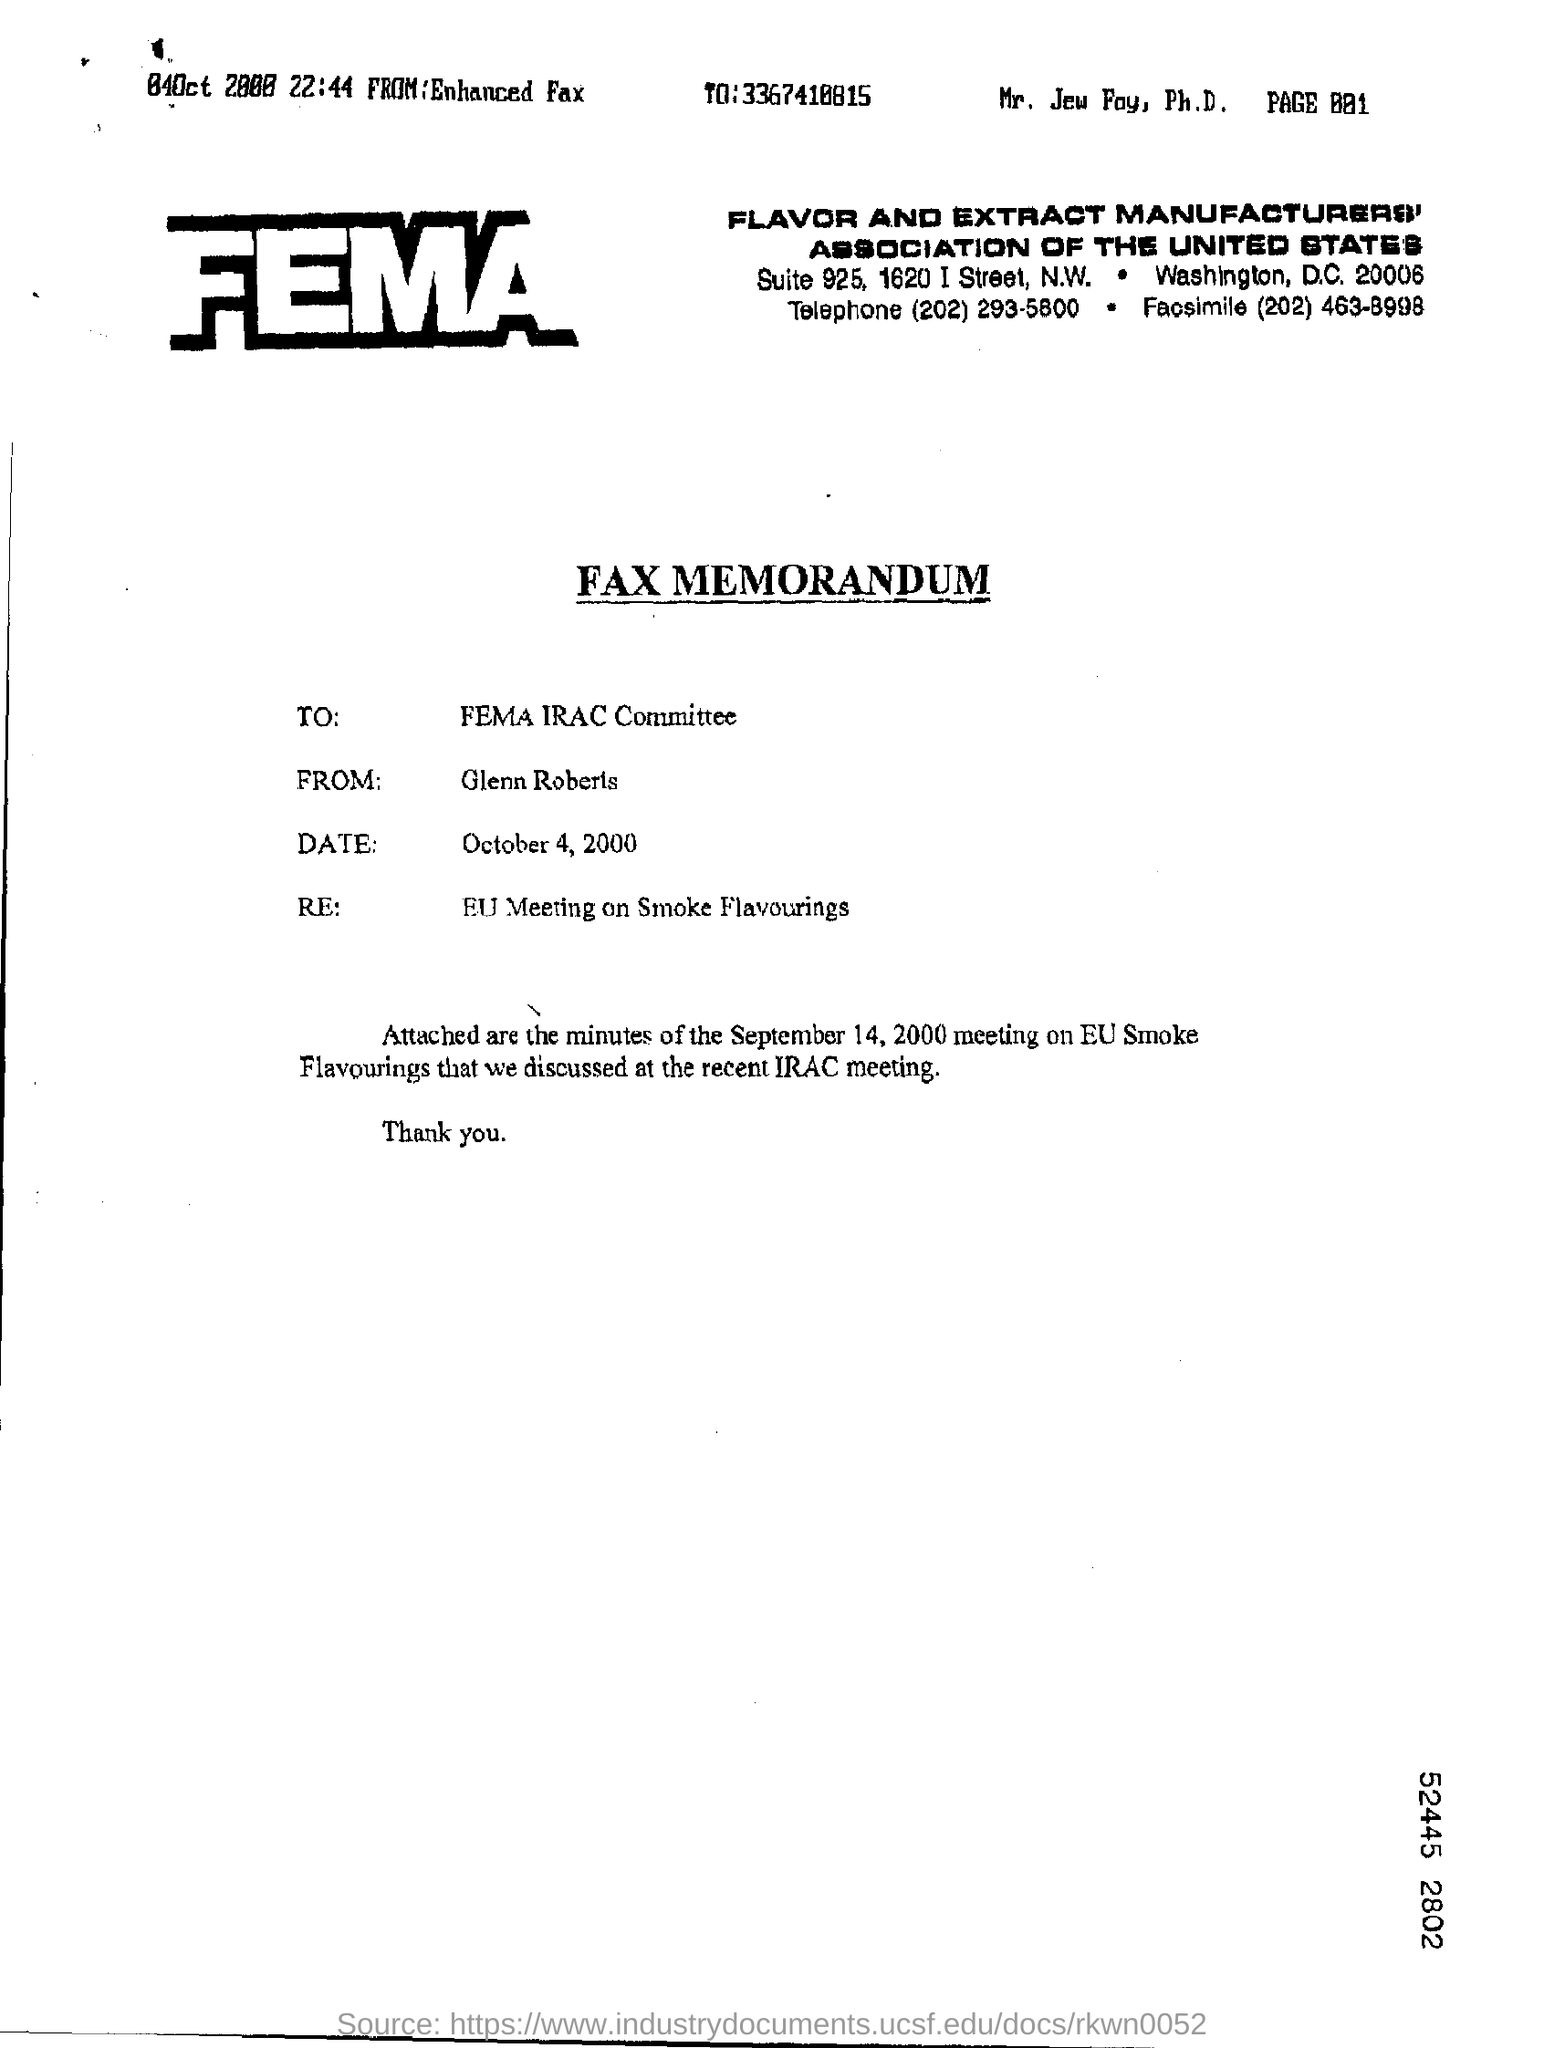Specify some key components in this picture. This type of communication is a FAX Memorandum. The memorandum was dated October 4, 2000. The telephone number mentioned on the letterhead of FEMA is (202) 293-5800. The meeting minutes attached to the memorandum are from September 14, 2000. The sender's name in the Fax Memorandum is Glenn Roberts. 